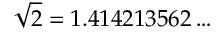<formula> <loc_0><loc_0><loc_500><loc_500>{ \sqrt { 2 } } = 1 . 4 1 4 2 1 3 5 6 2 \dots</formula> 